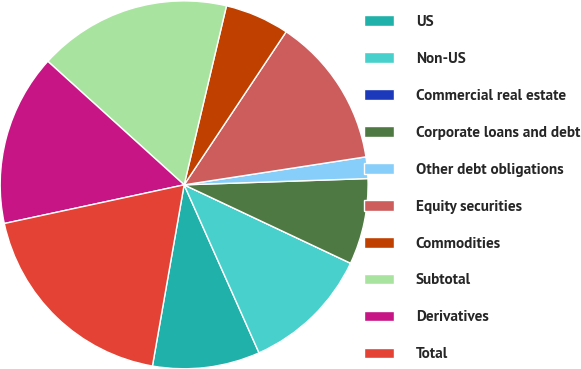<chart> <loc_0><loc_0><loc_500><loc_500><pie_chart><fcel>US<fcel>Non-US<fcel>Commercial real estate<fcel>Corporate loans and debt<fcel>Other debt obligations<fcel>Equity securities<fcel>Commodities<fcel>Subtotal<fcel>Derivatives<fcel>Total<nl><fcel>9.43%<fcel>11.32%<fcel>0.0%<fcel>7.55%<fcel>1.89%<fcel>13.21%<fcel>5.66%<fcel>16.98%<fcel>15.09%<fcel>18.87%<nl></chart> 